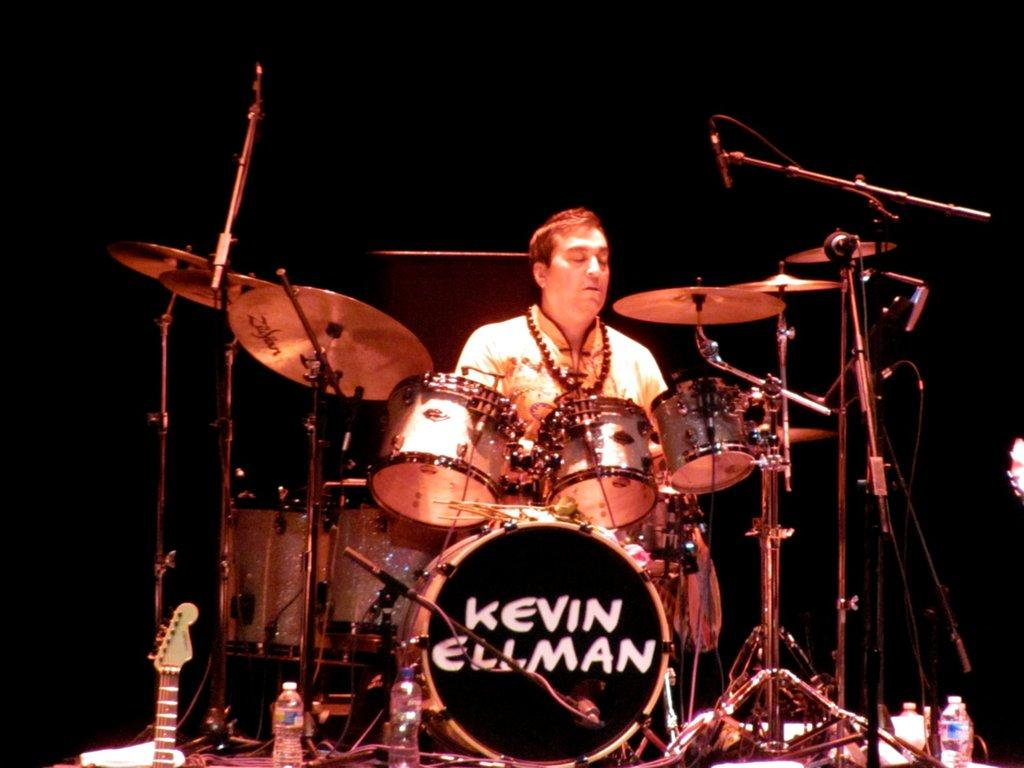What is the main activity being performed in the image? There is a man playing drums in the image. What can be seen in the front of the image? There is a band setup in the front of the image. What musical instrument is on the left side of the image? There is a guitar on the left side of the image. What object is on the right side of the image? There is a bottle on the right side of the image. How would you describe the lighting in the image? The background of the image is dark. How many rings are visible on the drummer's fingers in the image? There are no rings visible on the drummer's fingers in the image. Where is the spoon located in the image? There is no spoon present in the image. 